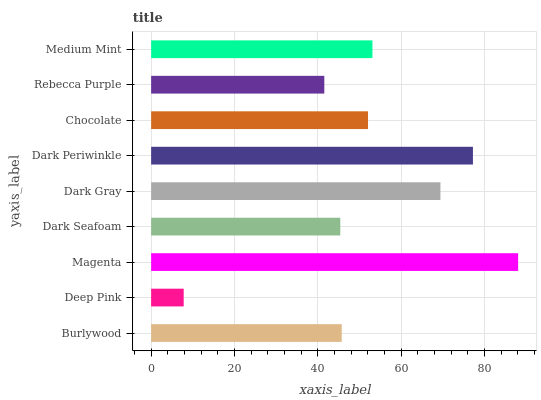Is Deep Pink the minimum?
Answer yes or no. Yes. Is Magenta the maximum?
Answer yes or no. Yes. Is Magenta the minimum?
Answer yes or no. No. Is Deep Pink the maximum?
Answer yes or no. No. Is Magenta greater than Deep Pink?
Answer yes or no. Yes. Is Deep Pink less than Magenta?
Answer yes or no. Yes. Is Deep Pink greater than Magenta?
Answer yes or no. No. Is Magenta less than Deep Pink?
Answer yes or no. No. Is Chocolate the high median?
Answer yes or no. Yes. Is Chocolate the low median?
Answer yes or no. Yes. Is Burlywood the high median?
Answer yes or no. No. Is Dark Seafoam the low median?
Answer yes or no. No. 